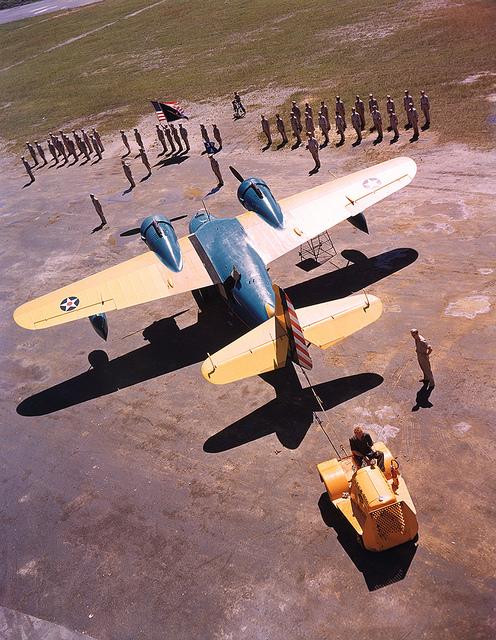Are we looking down at the plane?
Concise answer only. Yes. Where is the plane?
Write a very short answer. On ground. How high up is the airplane?
Write a very short answer. On ground. Is this plane jet powered?
Write a very short answer. No. 